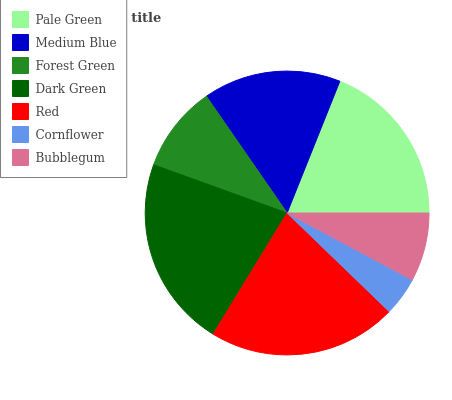Is Cornflower the minimum?
Answer yes or no. Yes. Is Dark Green the maximum?
Answer yes or no. Yes. Is Medium Blue the minimum?
Answer yes or no. No. Is Medium Blue the maximum?
Answer yes or no. No. Is Pale Green greater than Medium Blue?
Answer yes or no. Yes. Is Medium Blue less than Pale Green?
Answer yes or no. Yes. Is Medium Blue greater than Pale Green?
Answer yes or no. No. Is Pale Green less than Medium Blue?
Answer yes or no. No. Is Medium Blue the high median?
Answer yes or no. Yes. Is Medium Blue the low median?
Answer yes or no. Yes. Is Red the high median?
Answer yes or no. No. Is Dark Green the low median?
Answer yes or no. No. 